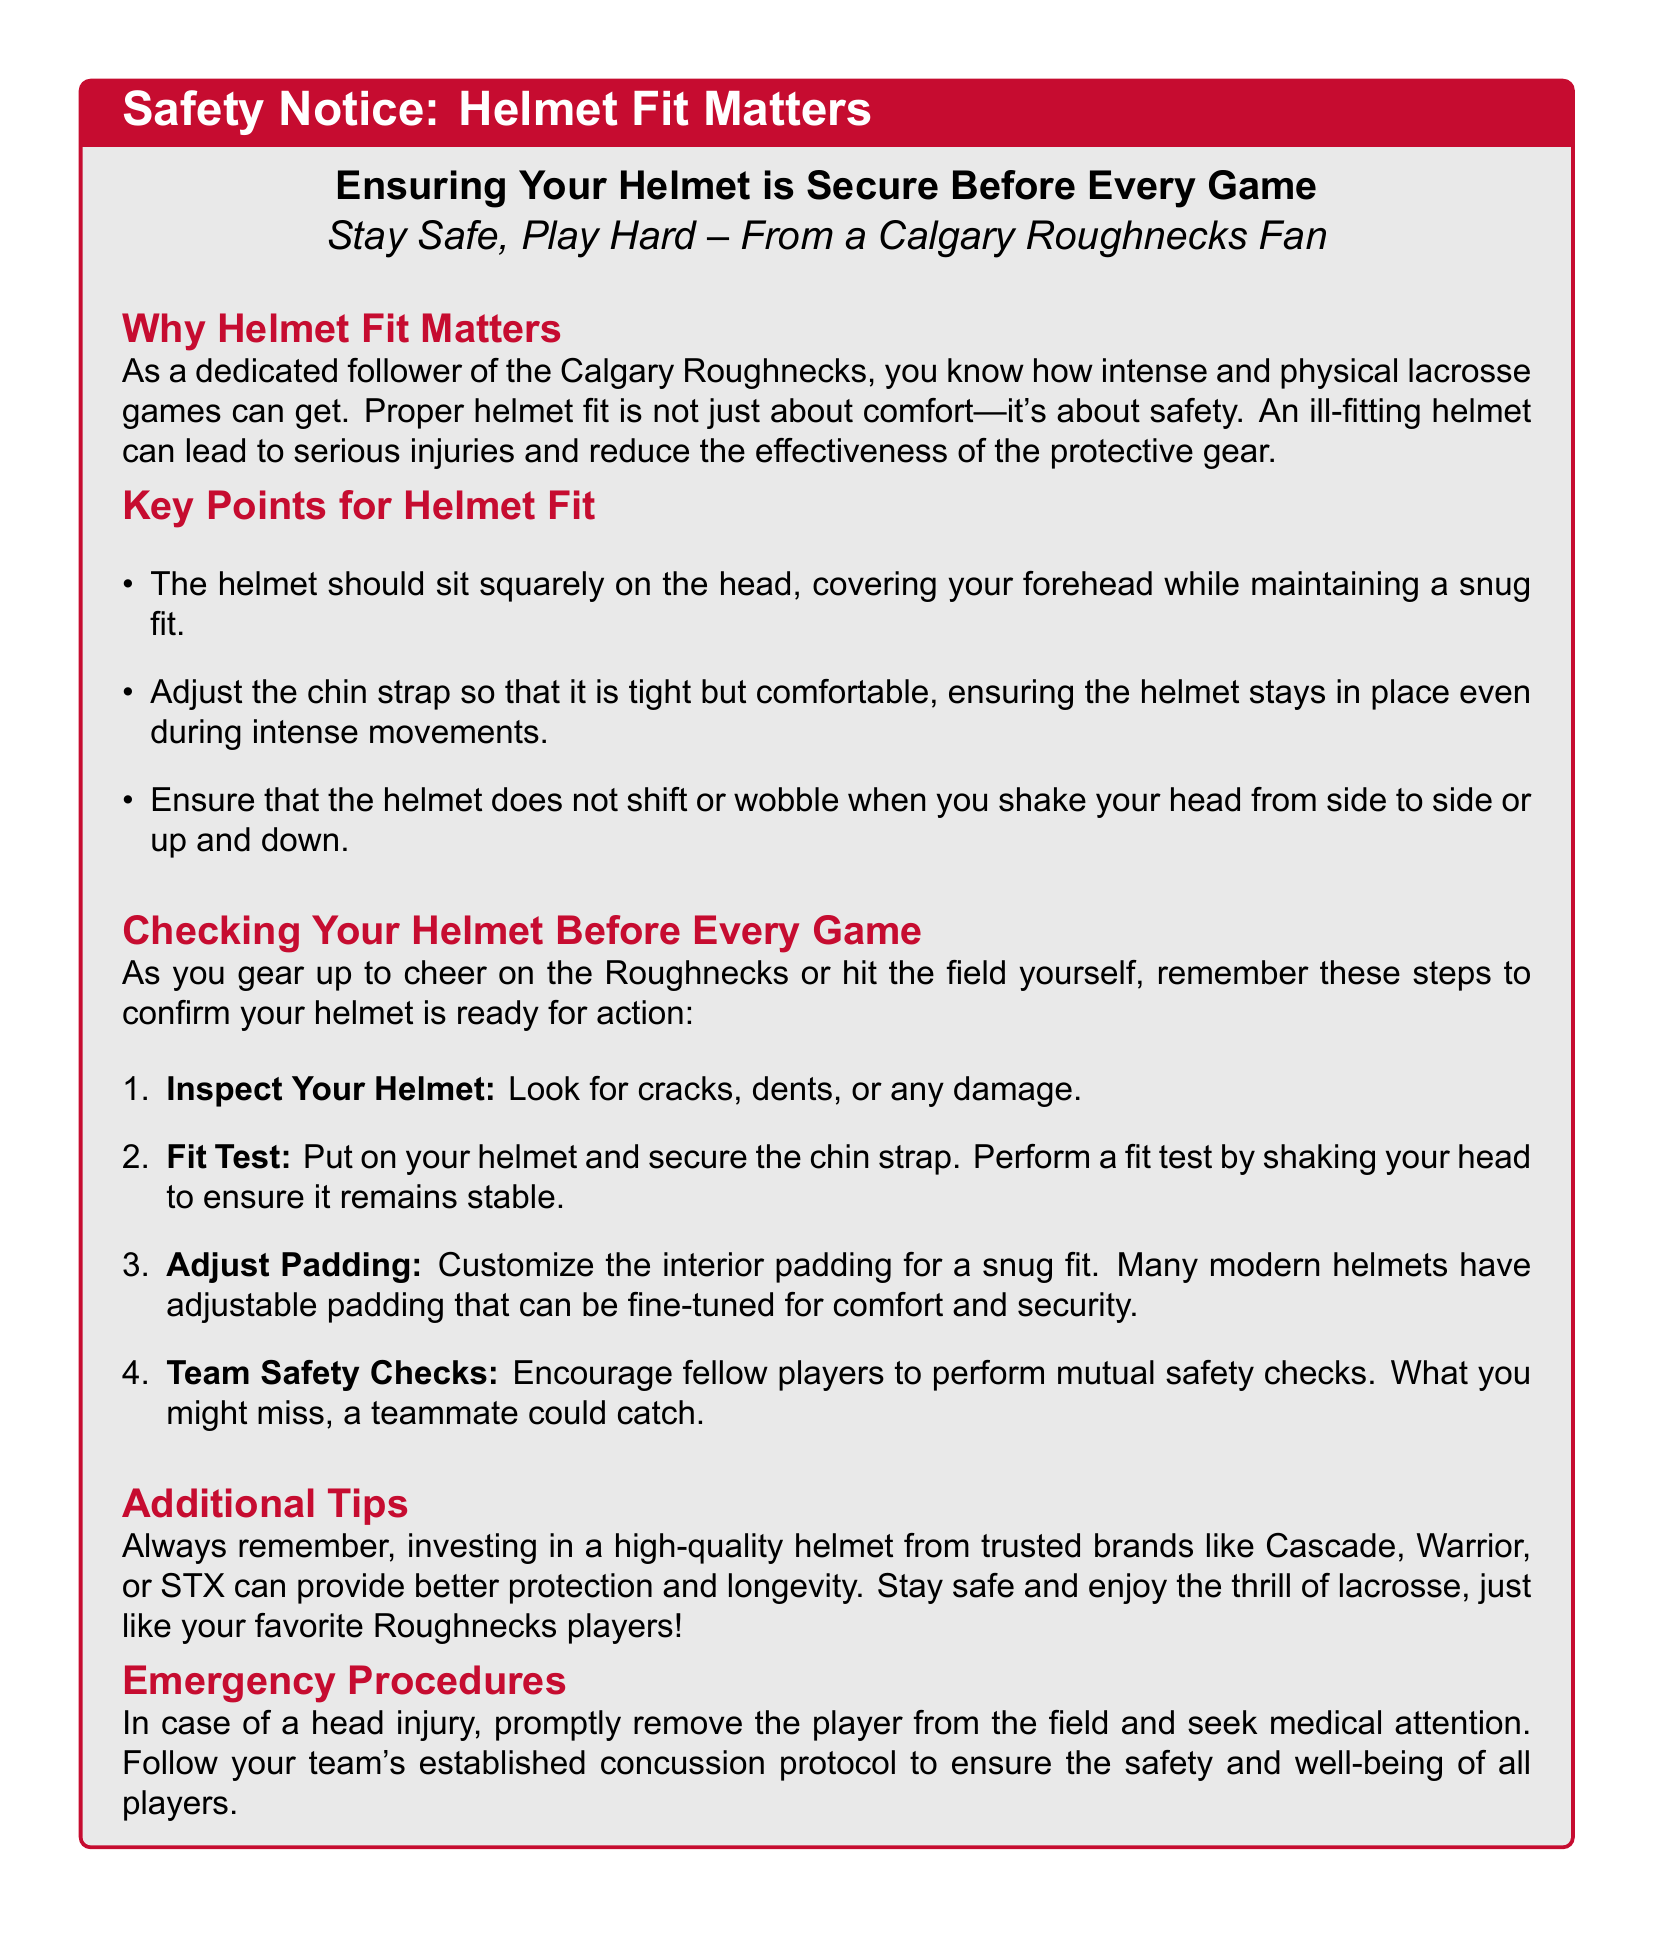What does the safety notice emphasize? The safety notice emphasizes the importance of ensuring helmet fit for safety while playing lacrosse.
Answer: Helmet fit matters What color is used for key points headings? The document uses roughnecksred color for all key point headings.
Answer: Roughnecksred What should you inspect your helmet for? The warning specifies inspecting the helmet for any damage before wearing it.
Answer: Cracks, dents, or any damage What is the first step to check your helmet before a game? The first step listed in the document is to inspect your helmet for damage.
Answer: Inspect Your Helmet Which helmet brands are mentioned? The notice includes trusted brands for helmets as examples.
Answer: Cascade, Warrior, or STX What should the chin strap be? The guidance states that the chin strap should be secured tightly.
Answer: Tight but comfortable What is the purpose of mutual safety checks? The document mentions that mutual safety checks help in ensuring that anything a player misses can be caught by a teammate.
Answer: Catching missed points What procedure is mentioned in case of a head injury? The document outlines the procedure for managing head injuries by seeking medical attention.
Answer: Seek medical attention 